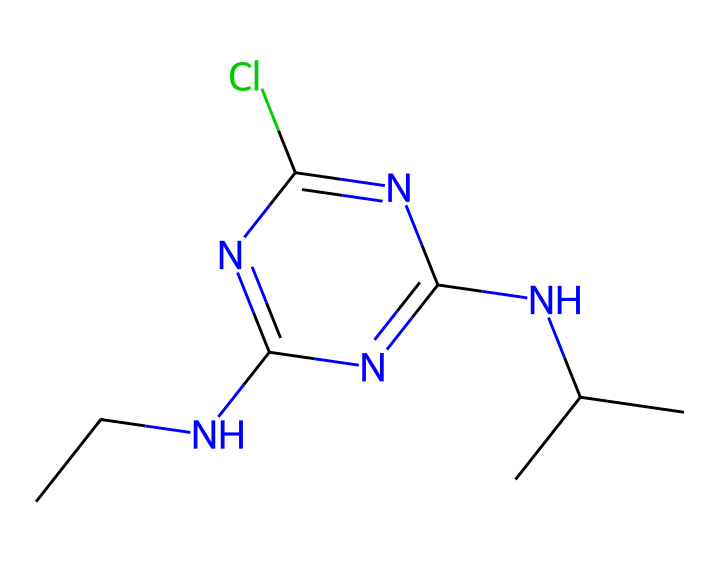How many carbon atoms are present in atrazine's structure? The SMILES representation shows several carbon atoms (C). Counting the "C" symbols and the branched forms reveals a total of 8 carbon atoms.
Answer: 8 What functional group is present in the atrazine structure? The atrazine structure contains a nitrogen atom (N) that bonds to carbon, indicating the presence of an amine functional group. The structure also shows a chloro group (Cl) attached to the aromatic ring, which is a characteristic of chlorine functional groups.
Answer: amine and chloro How many nitrogen atoms are in the atrazine molecule? By examining the SMILES representation, we identify three nitrogen atoms (N) in the molecular structure, indicating the presence of multiple amine functionalities.
Answer: 3 What is the potential impact of atrazine on amphibian development? Atrazine is known to disrupt endocrine systems, particularly affecting amphibians by causing developmental abnormalities such as hermaphroditism or altered reproductive behaviors.
Answer: endocrine disruption What makes atrazine classified as a herbicide? Atrazine works by inhibiting photosynthesis in plants, specifically by interfering with photosystem II, which classifies it as a herbicide due to its targeted action against unwanted plant growth.
Answer: inhibits photosynthesis What is the significance of chlorine in atrazine's structure concerning its environmental persistence? The presence of chlorine in atrazine contributes to its chemical stability, reducing degradation rates in the environment and leading to longer persistence in ecosystems.
Answer: environmental persistence 